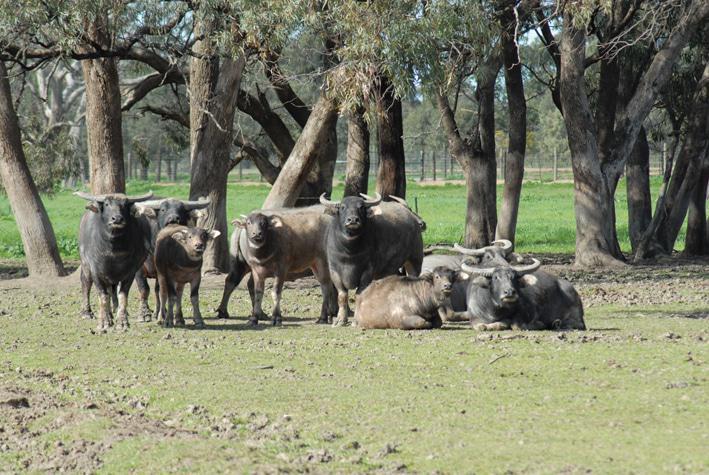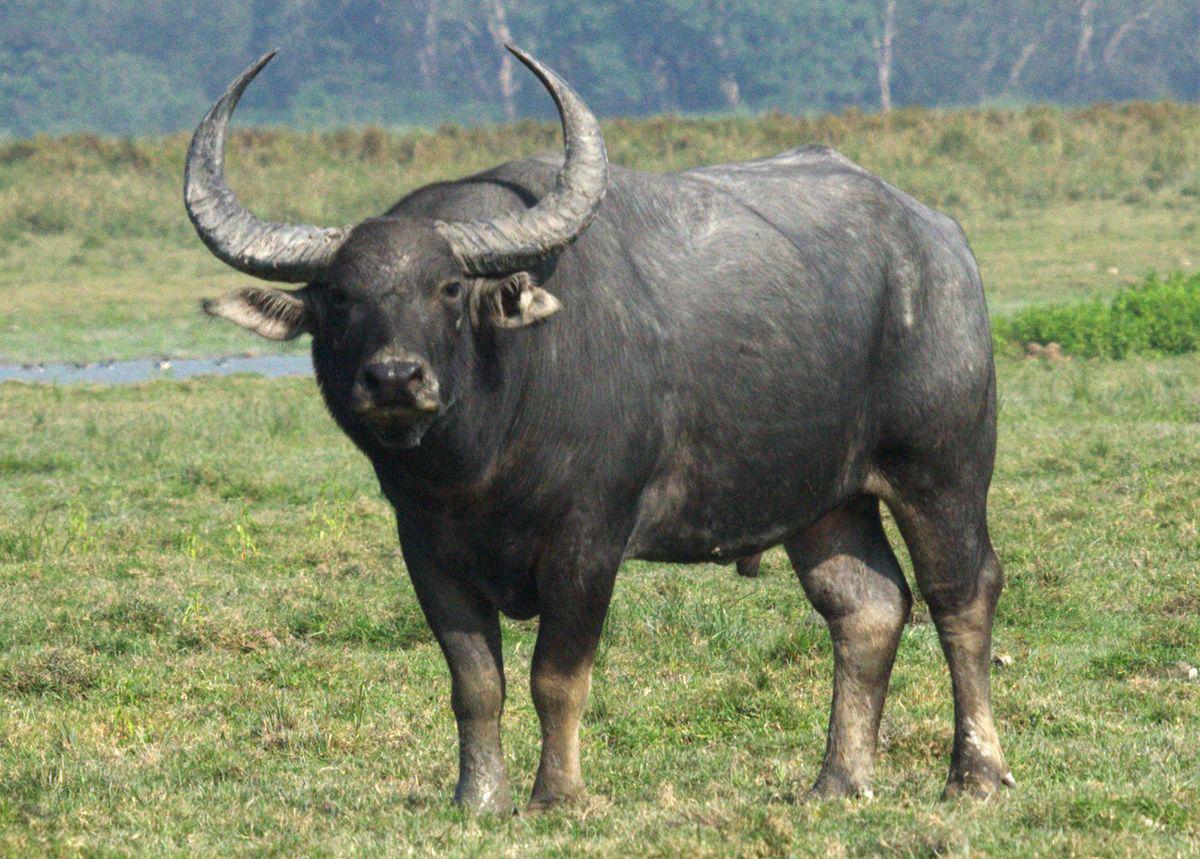The first image is the image on the left, the second image is the image on the right. Examine the images to the left and right. Is the description "Exactly two hooved animals are shown in one image." accurate? Answer yes or no. No. The first image is the image on the left, the second image is the image on the right. Given the left and right images, does the statement "One of the images contains exactly two steer" hold true? Answer yes or no. No. 